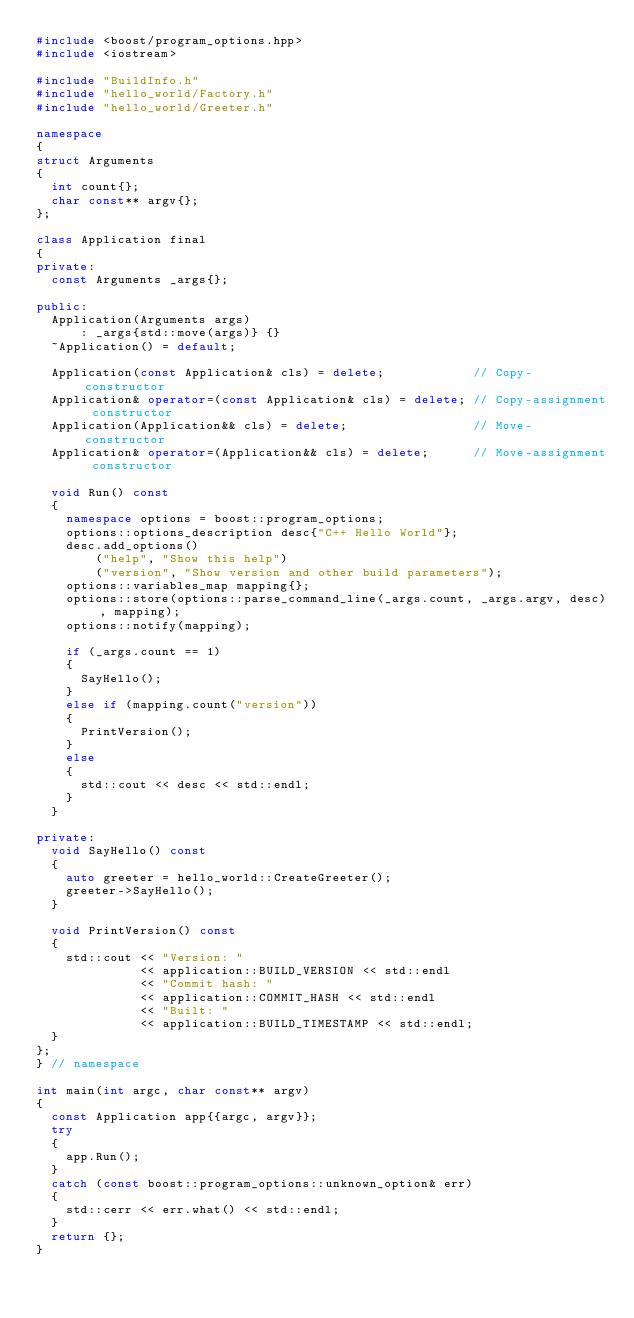Convert code to text. <code><loc_0><loc_0><loc_500><loc_500><_C++_>#include <boost/program_options.hpp>
#include <iostream>

#include "BuildInfo.h"
#include "hello_world/Factory.h"
#include "hello_world/Greeter.h"

namespace
{
struct Arguments
{
  int count{};
  char const** argv{};
};

class Application final
{
private:
  const Arguments _args{};

public:
  Application(Arguments args)
      : _args{std::move(args)} {}
  ~Application() = default;

  Application(const Application& cls) = delete;            // Copy-constructor
  Application& operator=(const Application& cls) = delete; // Copy-assignment constructor
  Application(Application&& cls) = delete;                 // Move-constructor
  Application& operator=(Application&& cls) = delete;      // Move-assignment constructor

  void Run() const
  {
    namespace options = boost::program_options;
    options::options_description desc{"C++ Hello World"};
    desc.add_options()
        ("help", "Show this help")
        ("version", "Show version and other build parameters");
    options::variables_map mapping{};
    options::store(options::parse_command_line(_args.count, _args.argv, desc), mapping);
    options::notify(mapping);

    if (_args.count == 1)
    {
      SayHello();
    }
    else if (mapping.count("version"))
    {
      PrintVersion();
    }
    else
    {
      std::cout << desc << std::endl;
    }
  }

private:
  void SayHello() const
  {
    auto greeter = hello_world::CreateGreeter();
    greeter->SayHello();
  }

  void PrintVersion() const
  {
    std::cout << "Version: "
              << application::BUILD_VERSION << std::endl
              << "Commit hash: "
              << application::COMMIT_HASH << std::endl
              << "Built: "
              << application::BUILD_TIMESTAMP << std::endl;
  }
};
} // namespace

int main(int argc, char const** argv)
{
  const Application app{{argc, argv}};
  try
  {
    app.Run();
  }
  catch (const boost::program_options::unknown_option& err)
  {
    std::cerr << err.what() << std::endl;
  }
  return {};
}
</code> 